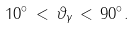Convert formula to latex. <formula><loc_0><loc_0><loc_500><loc_500>1 0 ^ { \circ } \, < \, \vartheta _ { \gamma } \, < \, 9 0 ^ { \circ } .</formula> 